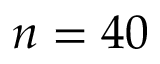Convert formula to latex. <formula><loc_0><loc_0><loc_500><loc_500>n = 4 0</formula> 